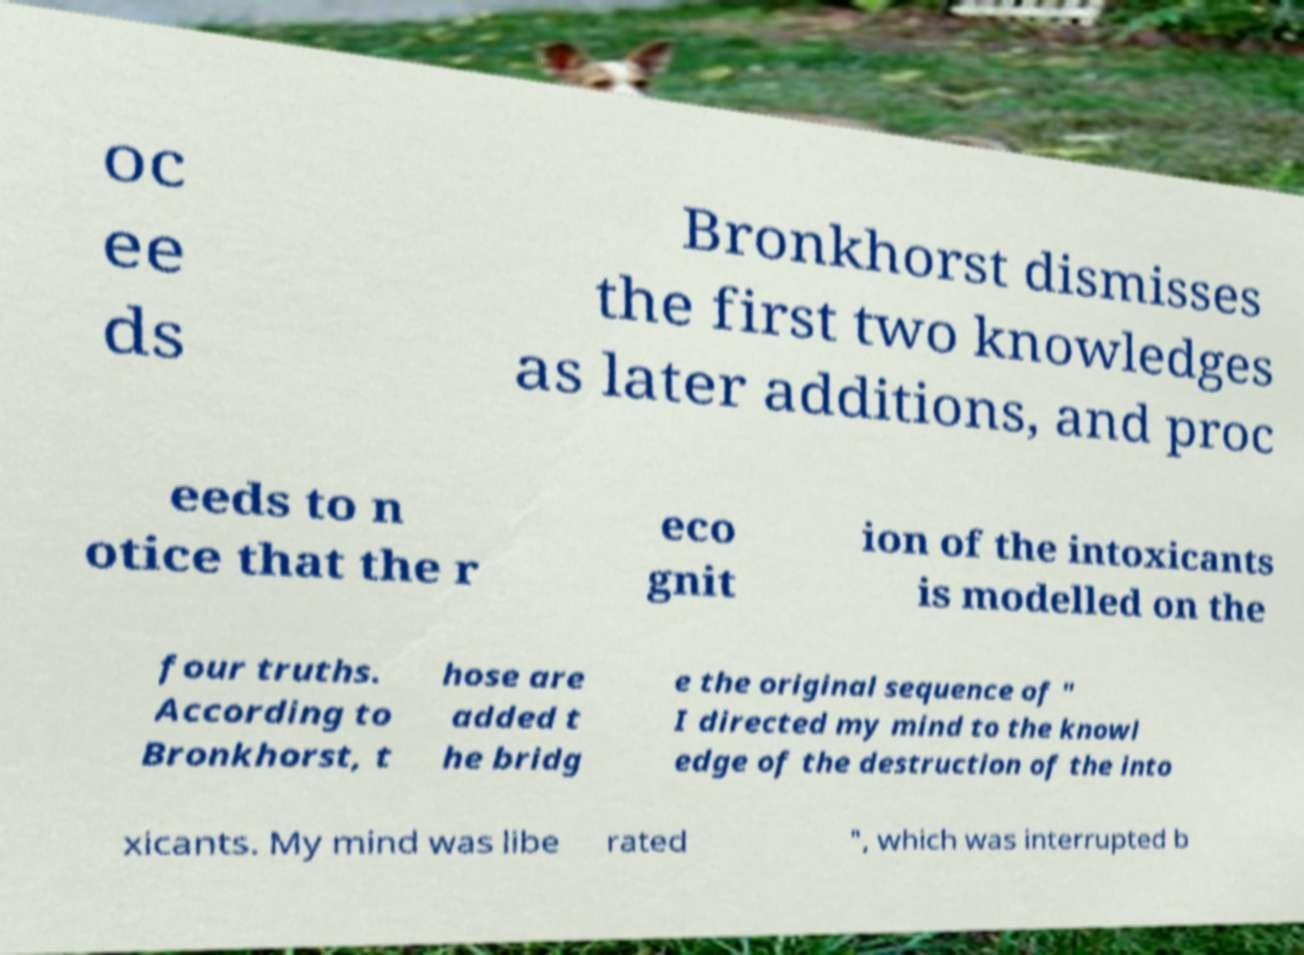There's text embedded in this image that I need extracted. Can you transcribe it verbatim? oc ee ds Bronkhorst dismisses the first two knowledges as later additions, and proc eeds to n otice that the r eco gnit ion of the intoxicants is modelled on the four truths. According to Bronkhorst, t hose are added t he bridg e the original sequence of " I directed my mind to the knowl edge of the destruction of the into xicants. My mind was libe rated ", which was interrupted b 